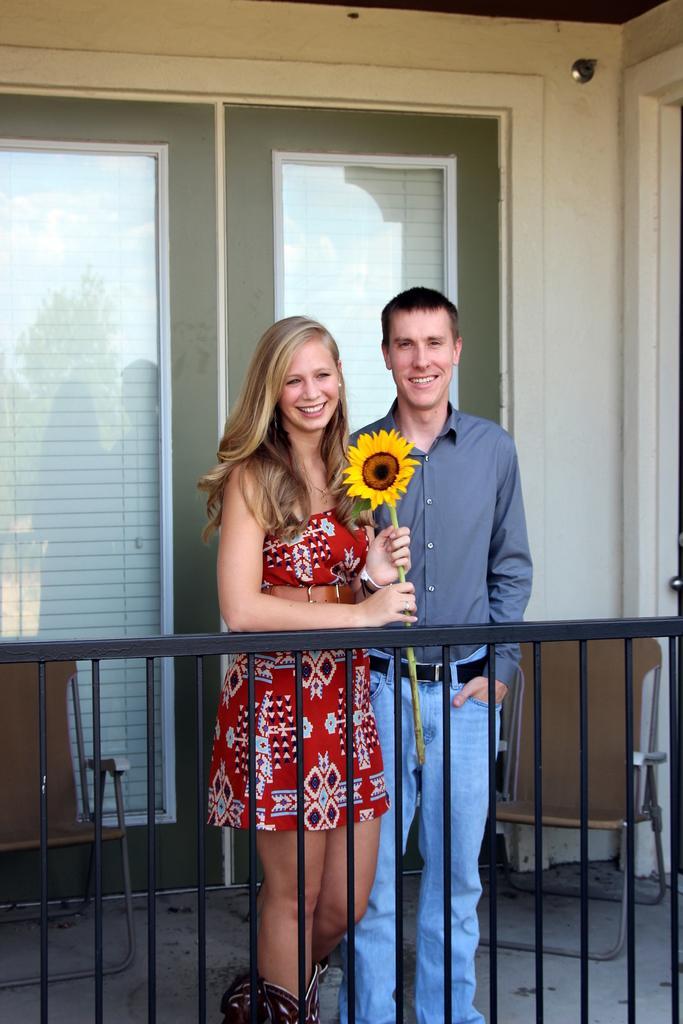Please provide a concise description of this image. In this image we can see a man and a woman standing on the floor and smiling. In addition to this we can see the woman is holding a sun flower in her hands, chair on the floor and windows. 